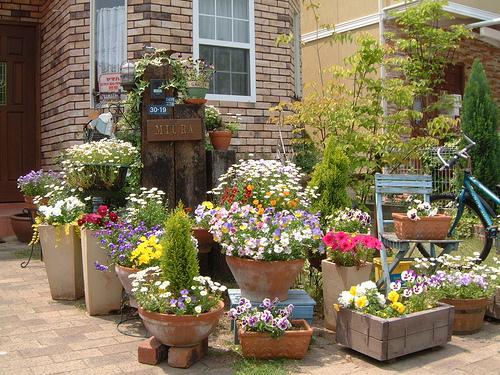How many planters are there?
Give a very brief answer. 15. What color is the bike?
Short answer required. Blue. What color is the chair?
Write a very short answer. Blue. 